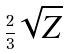<formula> <loc_0><loc_0><loc_500><loc_500>\frac { 2 } { 3 } \sqrt { Z }</formula> 